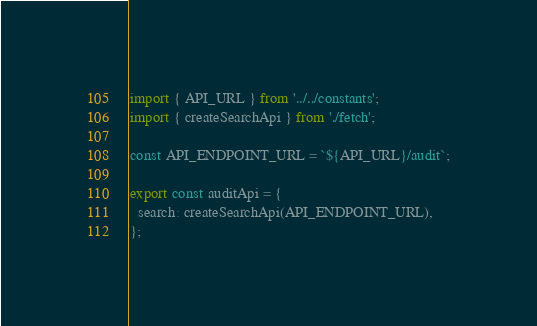<code> <loc_0><loc_0><loc_500><loc_500><_JavaScript_>import { API_URL } from '../../constants';
import { createSearchApi } from './fetch';

const API_ENDPOINT_URL = `${API_URL}/audit`;

export const auditApi = {
  search: createSearchApi(API_ENDPOINT_URL),
};
</code> 